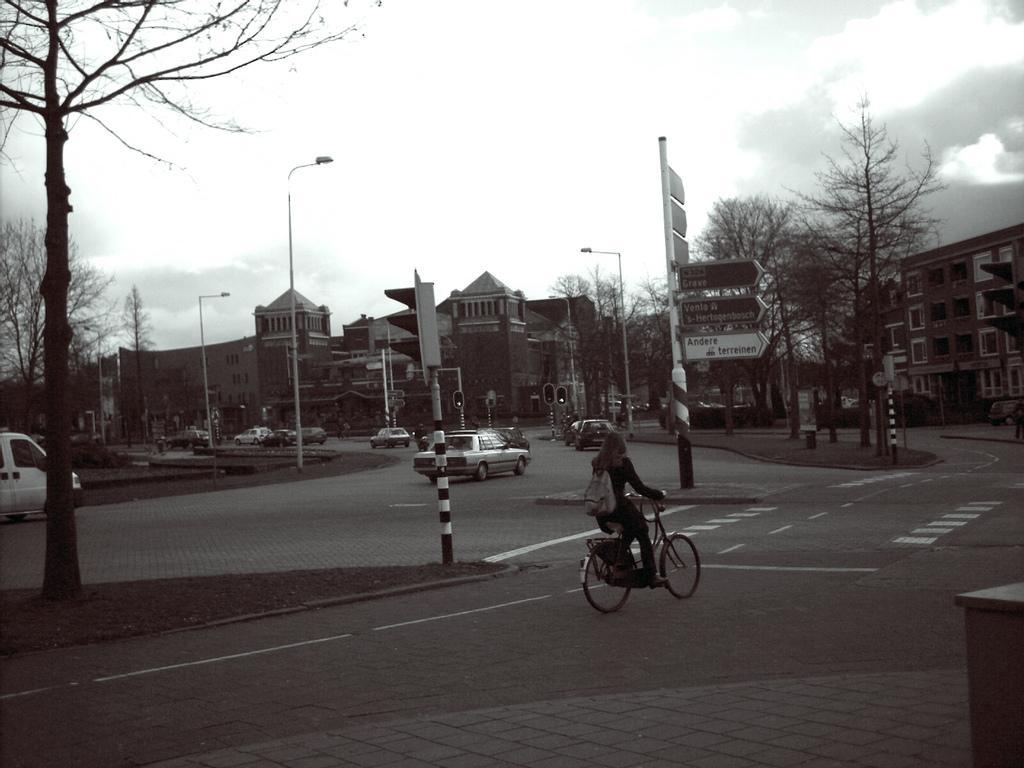Can you describe this image briefly? This picture is taken on the road. Where a woman is riding a bicycle at the right side. In the center car is running on the road. In the background there are buildings, trees, sign boards, sky and clouds. 